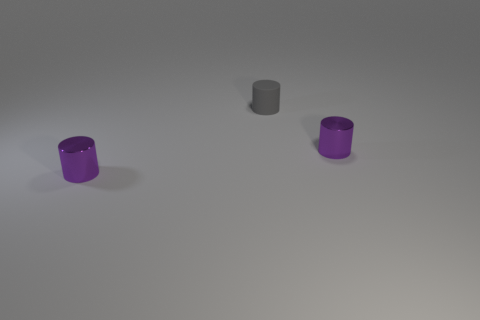How many large objects are either metal things or gray rubber objects?
Your answer should be very brief. 0. There is a gray rubber thing; what number of purple shiny cylinders are on the right side of it?
Your answer should be very brief. 1. Is there a tiny cube of the same color as the rubber cylinder?
Provide a short and direct response. No. How many red things are either rubber cylinders or small metal spheres?
Your response must be concise. 0. What number of purple metal cylinders have the same size as the gray cylinder?
Ensure brevity in your answer.  2. What number of objects are either tiny red metallic cubes or things on the right side of the gray object?
Keep it short and to the point. 1. What number of other gray objects are the same shape as the tiny rubber object?
Your answer should be compact. 0. What is the tiny purple thing that is on the left side of the metal cylinder that is behind the tiny purple metallic cylinder that is to the left of the small matte thing made of?
Offer a terse response. Metal. Does the matte cylinder have the same size as the purple object that is on the right side of the gray rubber cylinder?
Ensure brevity in your answer.  Yes. What is the material of the tiny purple thing that is right of the metal cylinder that is on the left side of the gray matte object?
Ensure brevity in your answer.  Metal. 